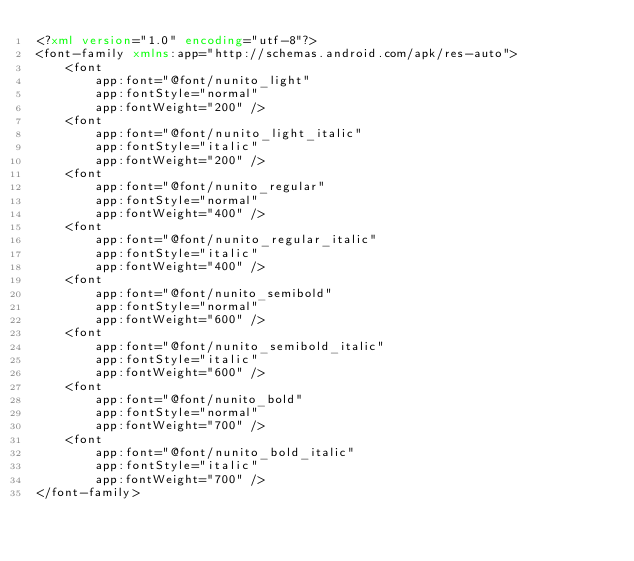Convert code to text. <code><loc_0><loc_0><loc_500><loc_500><_XML_><?xml version="1.0" encoding="utf-8"?>
<font-family xmlns:app="http://schemas.android.com/apk/res-auto">
    <font
        app:font="@font/nunito_light"
        app:fontStyle="normal"
        app:fontWeight="200" />
    <font
        app:font="@font/nunito_light_italic"
        app:fontStyle="italic"
        app:fontWeight="200" />
    <font
        app:font="@font/nunito_regular"
        app:fontStyle="normal"
        app:fontWeight="400" />
    <font
        app:font="@font/nunito_regular_italic"
        app:fontStyle="italic"
        app:fontWeight="400" />
    <font
        app:font="@font/nunito_semibold"
        app:fontStyle="normal"
        app:fontWeight="600" />
    <font
        app:font="@font/nunito_semibold_italic"
        app:fontStyle="italic"
        app:fontWeight="600" />
    <font
        app:font="@font/nunito_bold"
        app:fontStyle="normal"
        app:fontWeight="700" />
    <font
        app:font="@font/nunito_bold_italic"
        app:fontStyle="italic"
        app:fontWeight="700" />
</font-family>
</code> 